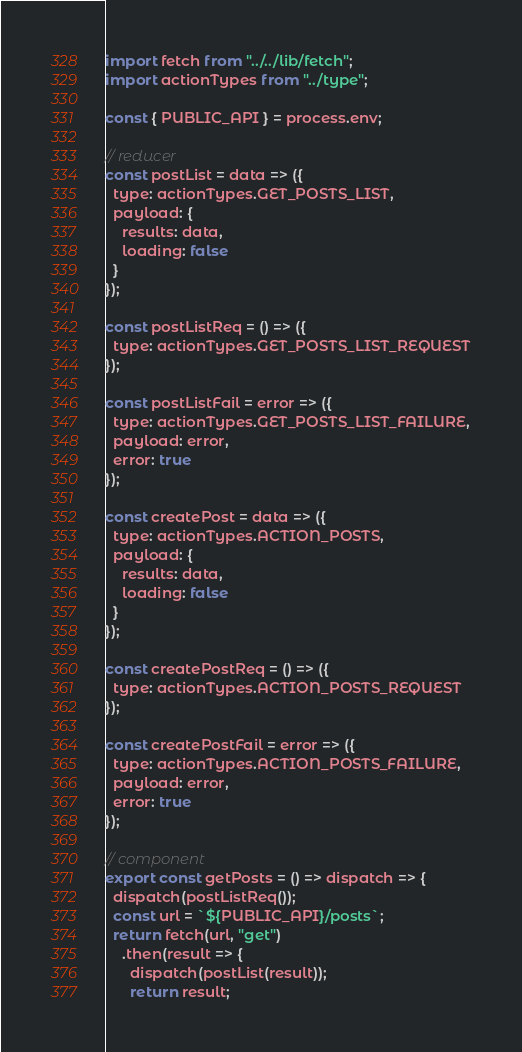<code> <loc_0><loc_0><loc_500><loc_500><_JavaScript_>import fetch from "../../lib/fetch";
import actionTypes from "../type";

const { PUBLIC_API } = process.env;

// reducer
const postList = data => ({
  type: actionTypes.GET_POSTS_LIST,
  payload: {
    results: data,
    loading: false
  }
});

const postListReq = () => ({
  type: actionTypes.GET_POSTS_LIST_REQUEST
});

const postListFail = error => ({
  type: actionTypes.GET_POSTS_LIST_FAILURE,
  payload: error,
  error: true
});

const createPost = data => ({
  type: actionTypes.ACTION_POSTS,
  payload: {
    results: data,
    loading: false
  }
});

const createPostReq = () => ({
  type: actionTypes.ACTION_POSTS_REQUEST
});

const createPostFail = error => ({
  type: actionTypes.ACTION_POSTS_FAILURE,
  payload: error,
  error: true
});

// component
export const getPosts = () => dispatch => {
  dispatch(postListReq());
  const url = `${PUBLIC_API}/posts`;
  return fetch(url, "get")
    .then(result => {
      dispatch(postList(result));
      return result;</code> 